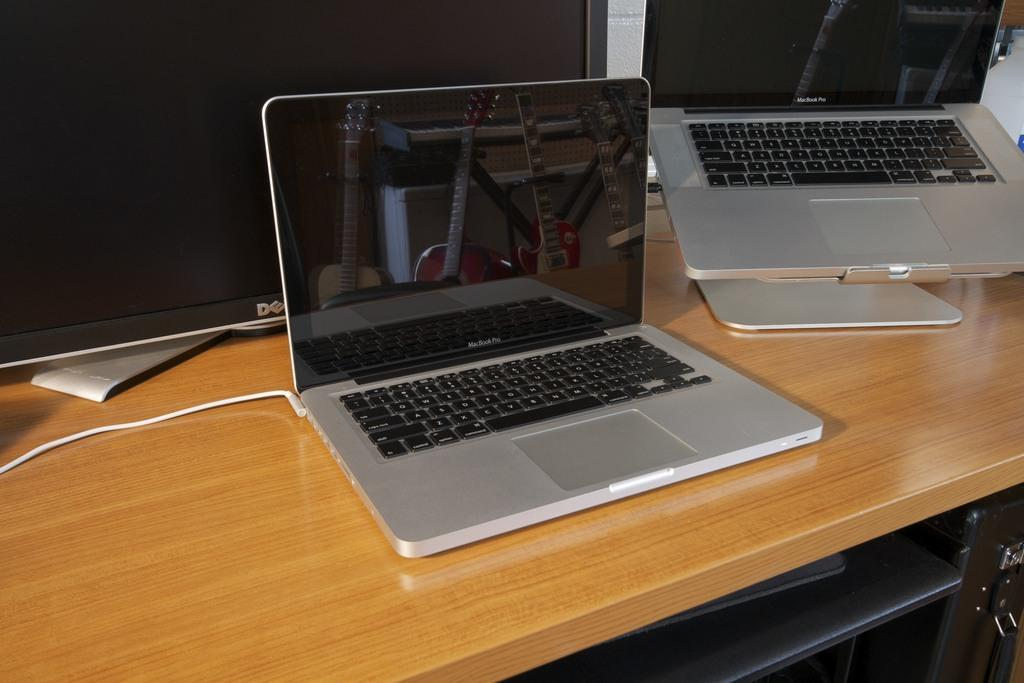What piece of furniture is present in the image? There is a table in the image. What electronic devices are on the table? There are two laptops on the table. What type of display is on the table? There is an LCD display on the table. How many brothers are sitting at the table in the image? There is no information about any people, let alone brothers, in the image. 